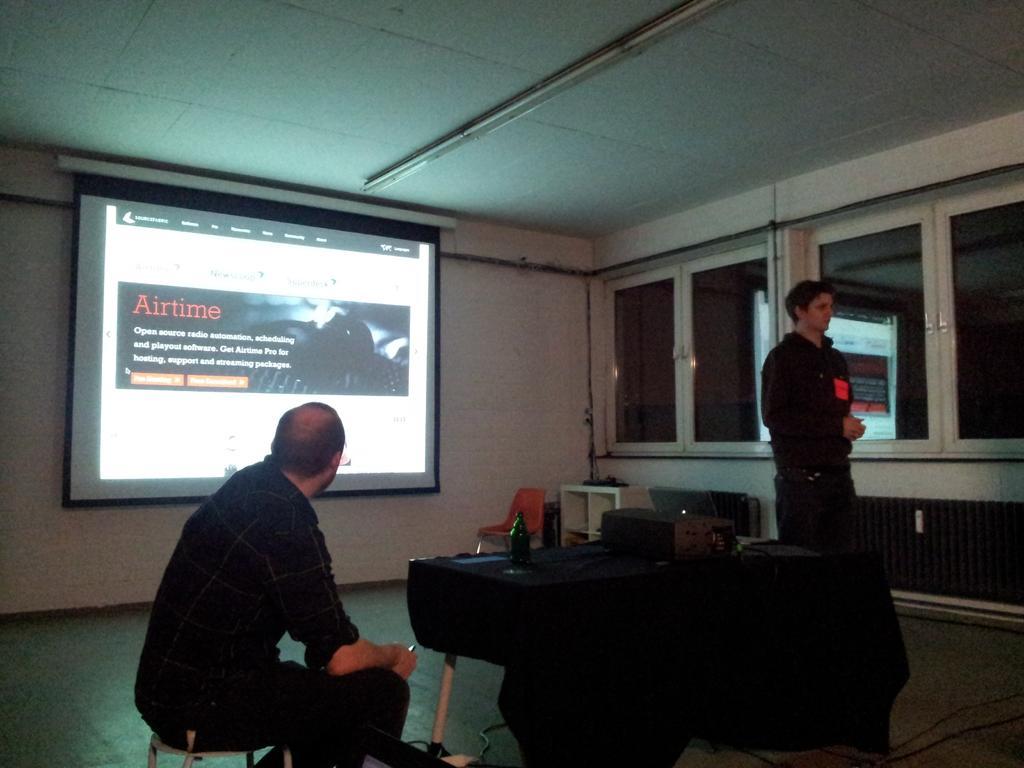Describe this image in one or two sentences. In this image I can see one person sitting on the table and there is an other person standing. There is a table and there are some objects on it. There is a chair, wall, ceiling and there are glass doors. Also there are some objects on the floor. 